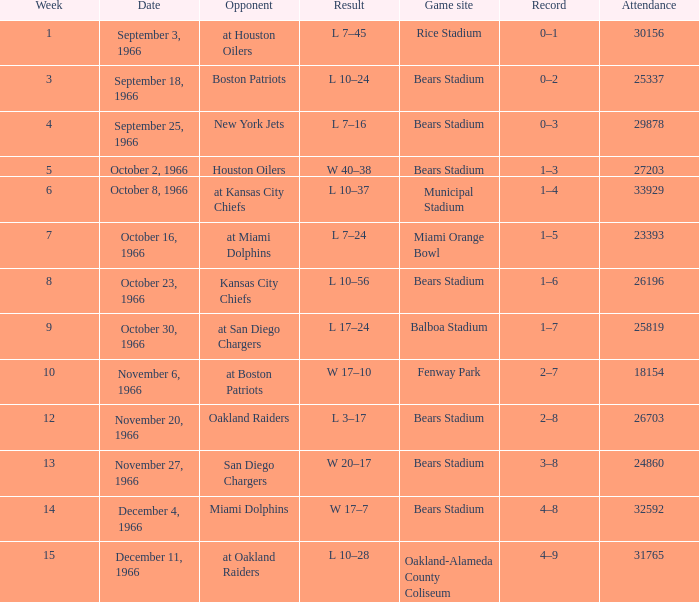What was the date of the game when the opponent was the Miami Dolphins? December 4, 1966. 